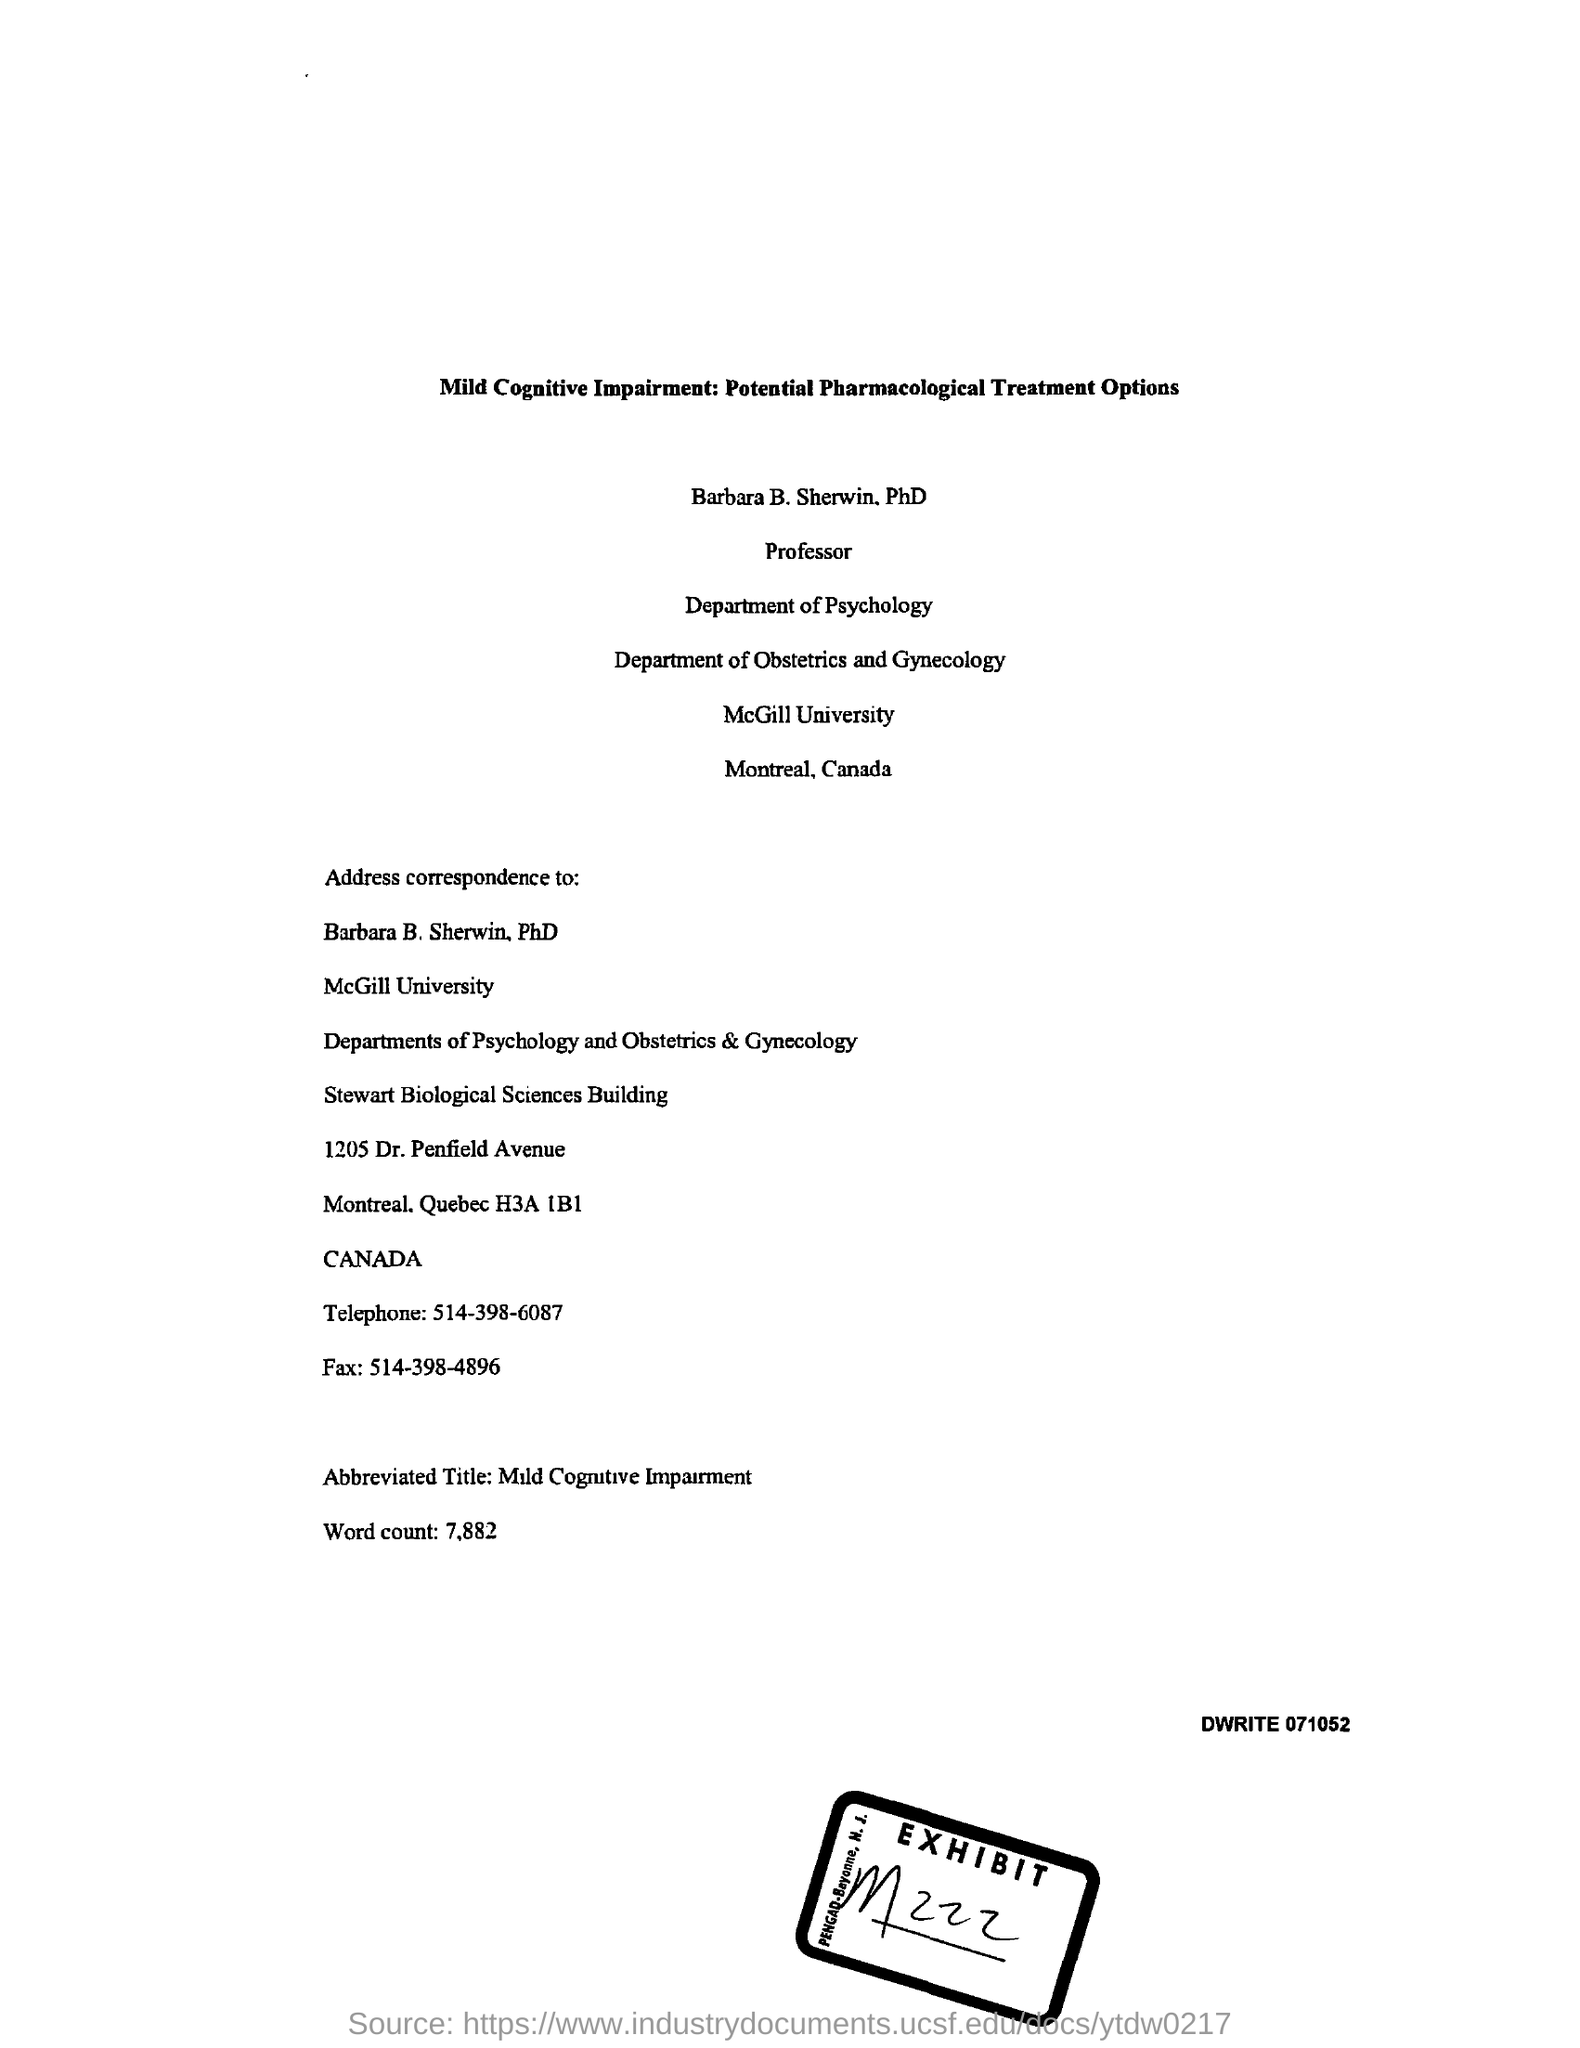What is the Exhibit number?
Offer a very short reply. M 222. What is the abbreviated title?
Keep it short and to the point. Mild Cognitive Impairment. What is the Fax number?
Make the answer very short. 514-398-4896. What is the telephone number?
Keep it short and to the point. 514-398-6087. What is the word count?
Your response must be concise. 7,882. 